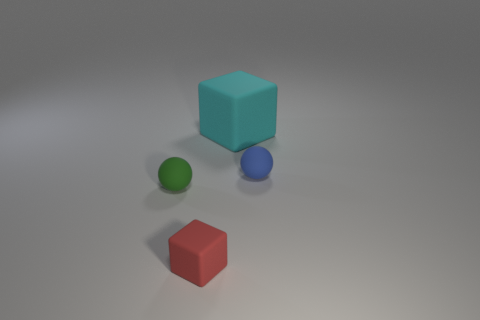How many other objects are there of the same material as the green sphere?
Provide a short and direct response. 3. Is the shape of the tiny blue rubber object the same as the green matte object?
Your response must be concise. Yes. There is a green rubber object that is on the left side of the blue rubber object; what size is it?
Keep it short and to the point. Small. There is a red block; is its size the same as the matte block behind the tiny green object?
Your answer should be very brief. No. Is the number of green objects to the right of the red matte block less than the number of small purple rubber blocks?
Provide a short and direct response. No. There is another tiny object that is the same shape as the cyan thing; what is its material?
Keep it short and to the point. Rubber. The rubber object that is both behind the red cube and on the left side of the large block has what shape?
Offer a terse response. Sphere. There is a small green thing that is made of the same material as the small blue ball; what is its shape?
Give a very brief answer. Sphere. Is the size of the matte cube that is behind the blue sphere the same as the cube in front of the small blue matte object?
Keep it short and to the point. No. The large rubber cube has what color?
Provide a succinct answer. Cyan. 